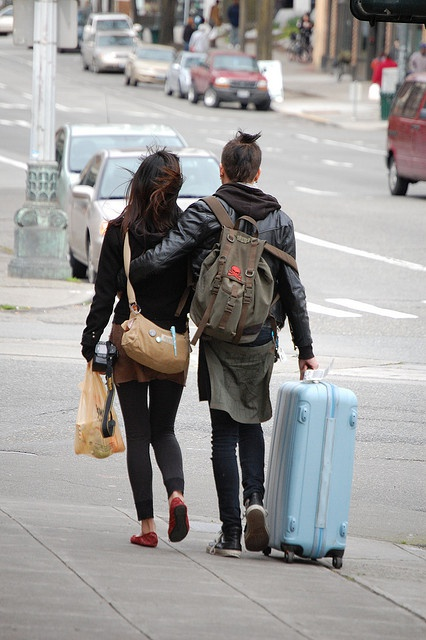Describe the objects in this image and their specific colors. I can see people in darkgray, black, and gray tones, people in darkgray, black, lightgray, and gray tones, suitcase in darkgray, lightblue, and gray tones, car in darkgray, lightgray, and gray tones, and backpack in darkgray, gray, and black tones in this image. 